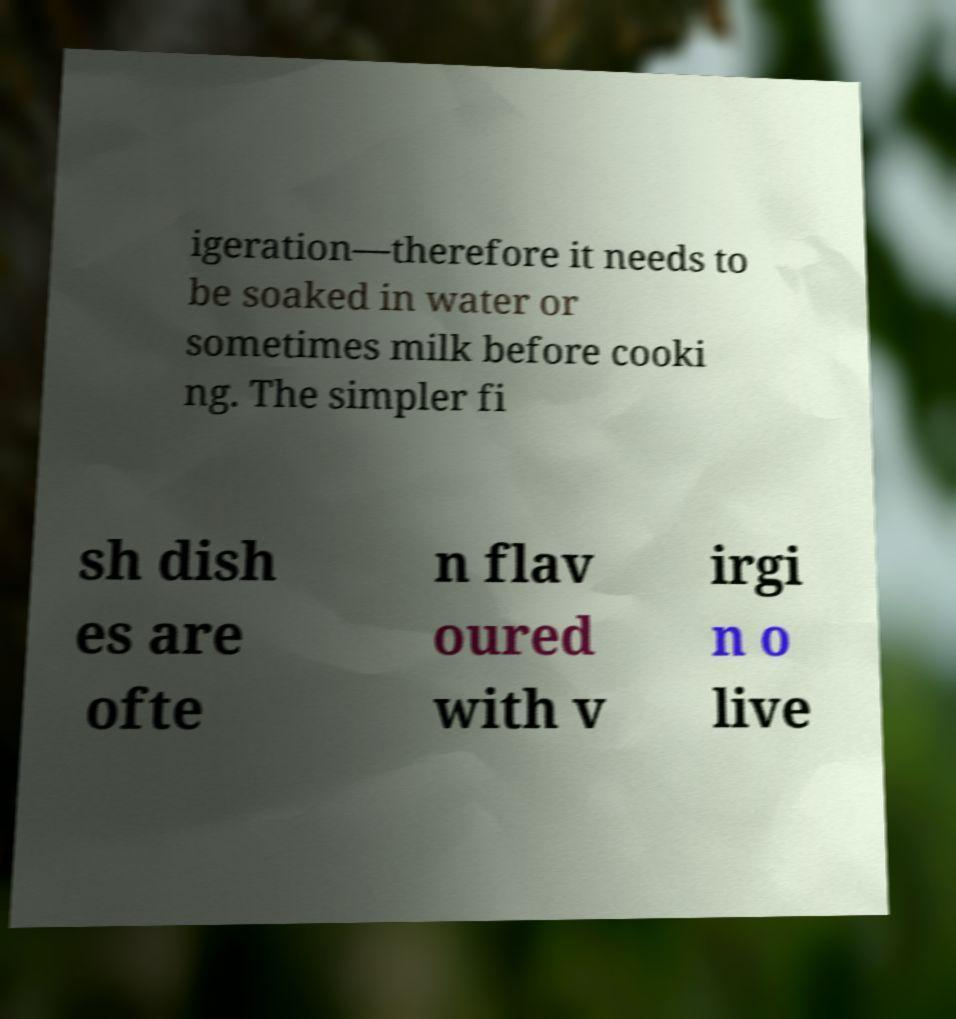Could you assist in decoding the text presented in this image and type it out clearly? igeration—therefore it needs to be soaked in water or sometimes milk before cooki ng. The simpler fi sh dish es are ofte n flav oured with v irgi n o live 